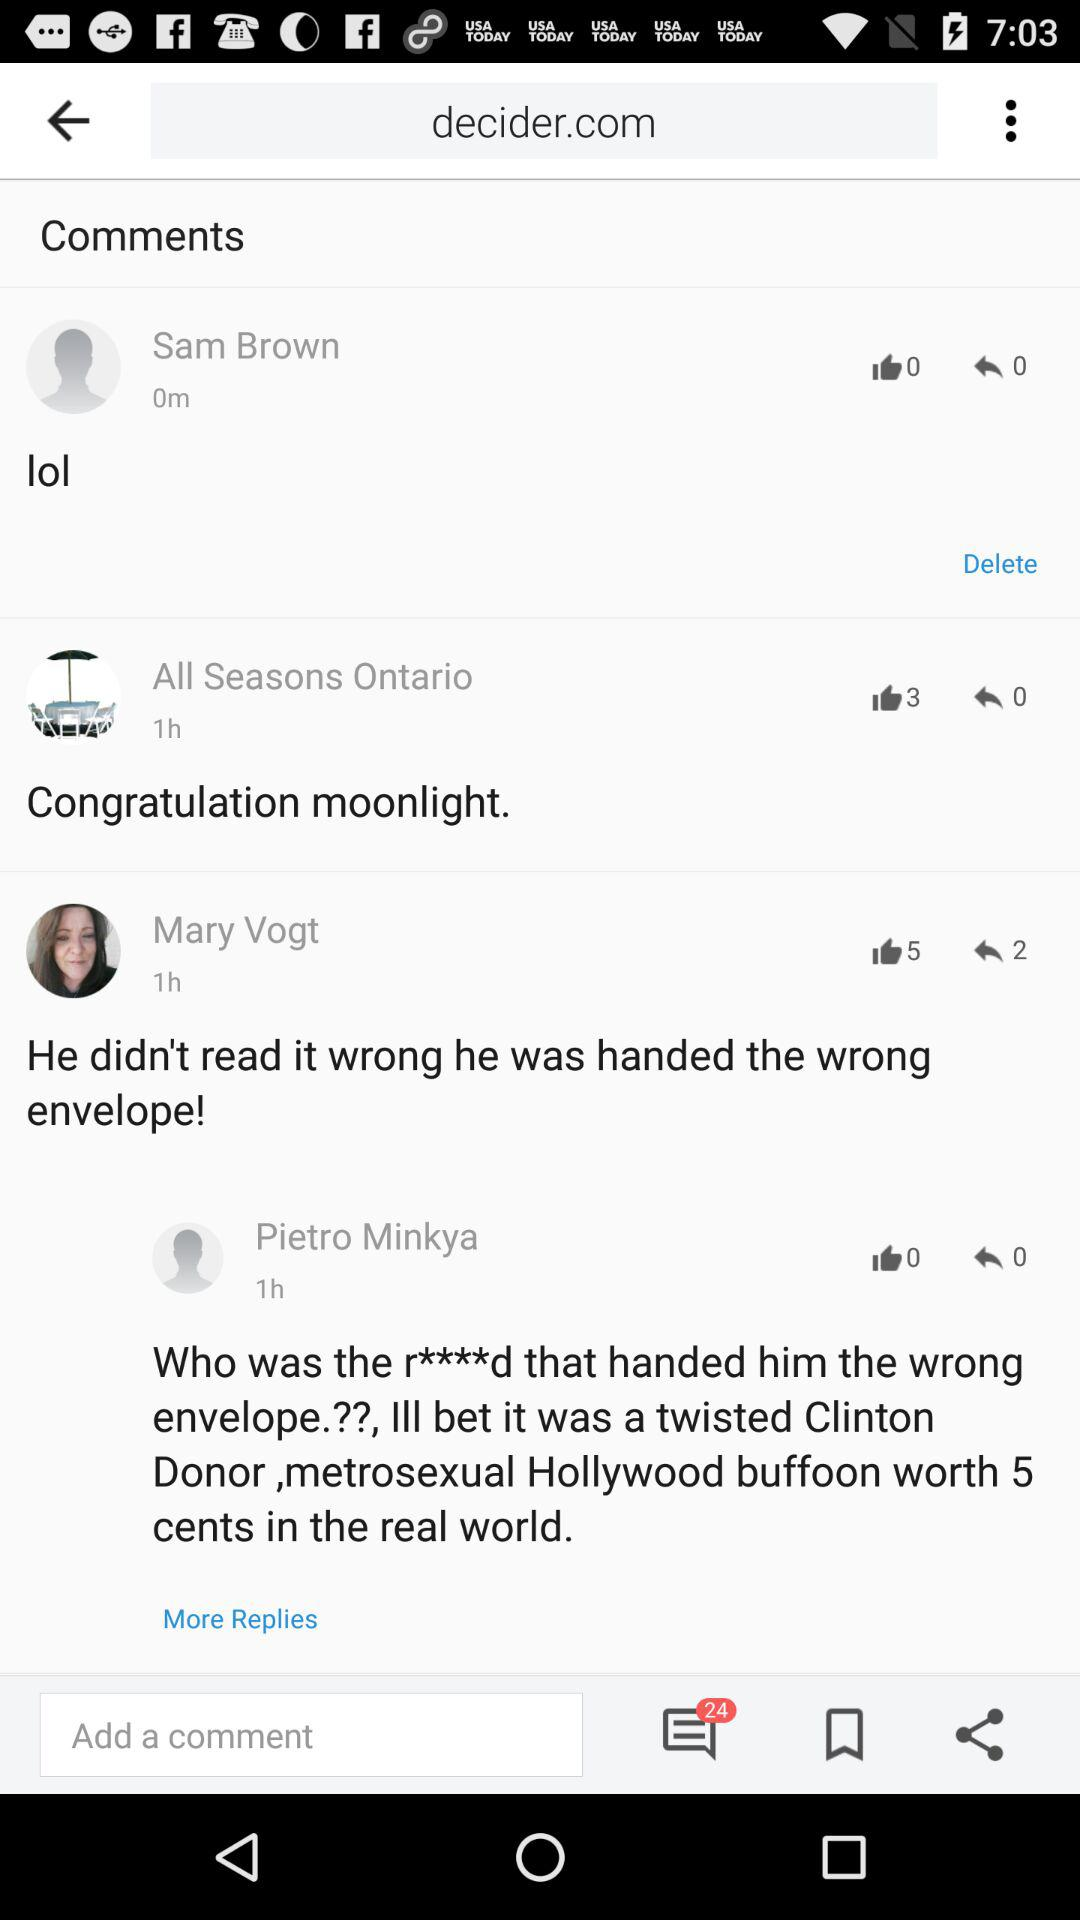How many unread chats are there? There are 24 unread chats. 